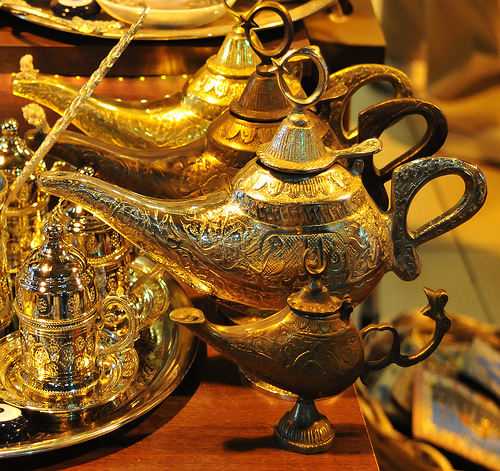<image>
Is there a genie lamp above the table? No. The genie lamp is not positioned above the table. The vertical arrangement shows a different relationship. Is there a lamp on the table? Yes. Looking at the image, I can see the lamp is positioned on top of the table, with the table providing support. Is the lid on the lamp? Yes. Looking at the image, I can see the lid is positioned on top of the lamp, with the lamp providing support. 